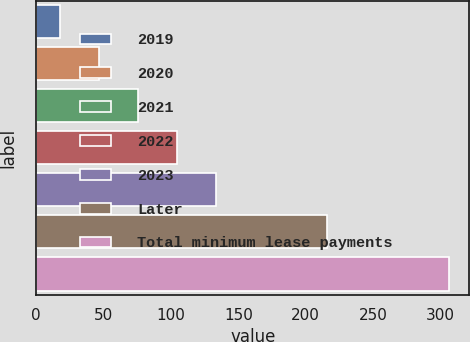Convert chart to OTSL. <chart><loc_0><loc_0><loc_500><loc_500><bar_chart><fcel>2019<fcel>2020<fcel>2021<fcel>2022<fcel>2023<fcel>Later<fcel>Total minimum lease payments<nl><fcel>18<fcel>46.8<fcel>75.6<fcel>104.4<fcel>133.2<fcel>216<fcel>306<nl></chart> 